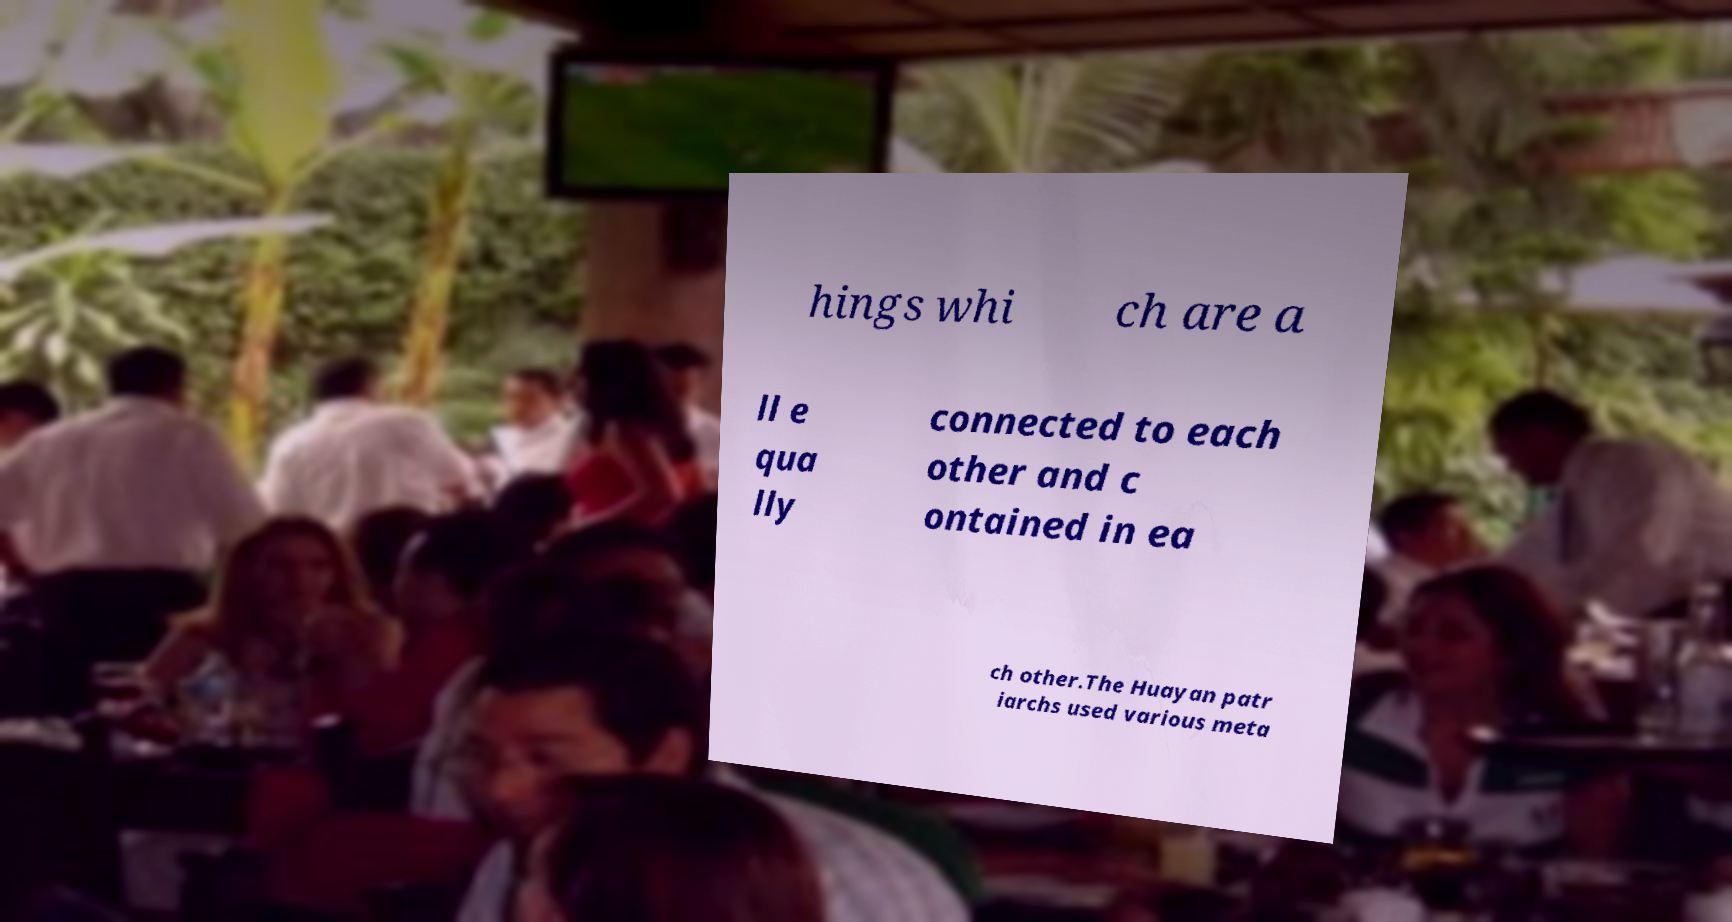Can you read and provide the text displayed in the image?This photo seems to have some interesting text. Can you extract and type it out for me? hings whi ch are a ll e qua lly connected to each other and c ontained in ea ch other.The Huayan patr iarchs used various meta 